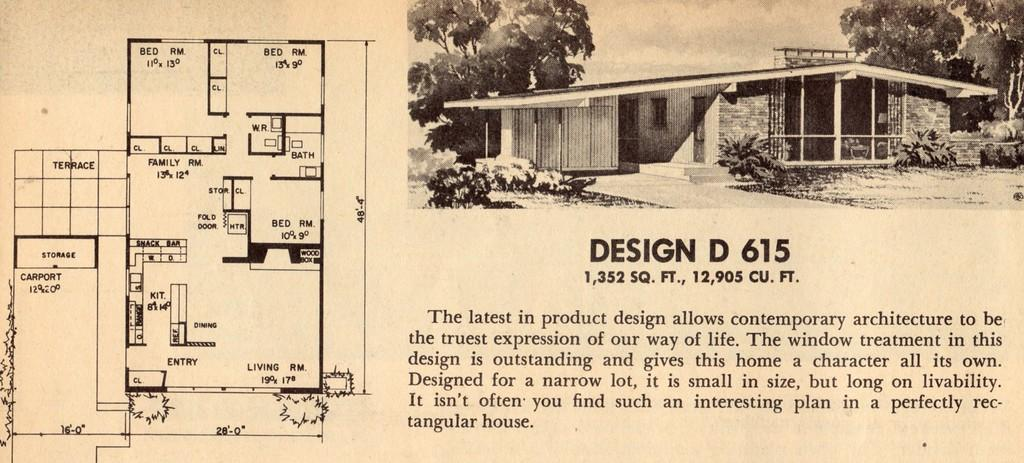What is depicted on the paper in the image? The paper contains a building plan and a building. What type of vegetation can be seen in the image? There are trees and plants in the image. What can be found on the paper besides the building plan and building? There are words and numbers on the paper. Can you tell me how many cows are grazing in the image? There are no cows present in the image. What is the reason for the building plan in the image? The image does not provide information about the reason for the building plan. 